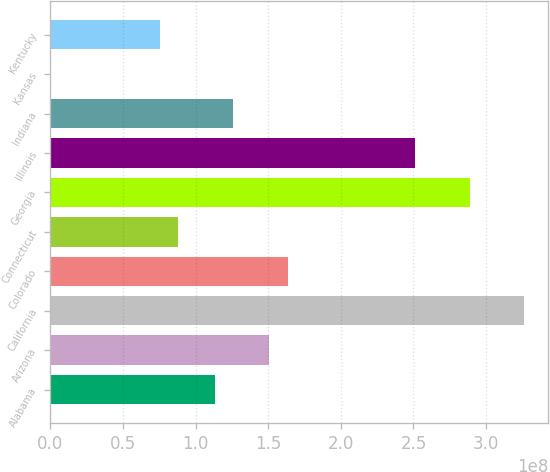Convert chart to OTSL. <chart><loc_0><loc_0><loc_500><loc_500><bar_chart><fcel>Alabama<fcel>Arizona<fcel>California<fcel>Colorado<fcel>Connecticut<fcel>Georgia<fcel>Illinois<fcel>Indiana<fcel>Kansas<fcel>Kentucky<nl><fcel>1.1314e+08<fcel>1.50777e+08<fcel>3.26416e+08<fcel>1.63322e+08<fcel>8.80482e+07<fcel>2.88779e+08<fcel>2.51142e+08<fcel>1.25685e+08<fcel>228489<fcel>7.55026e+07<nl></chart> 